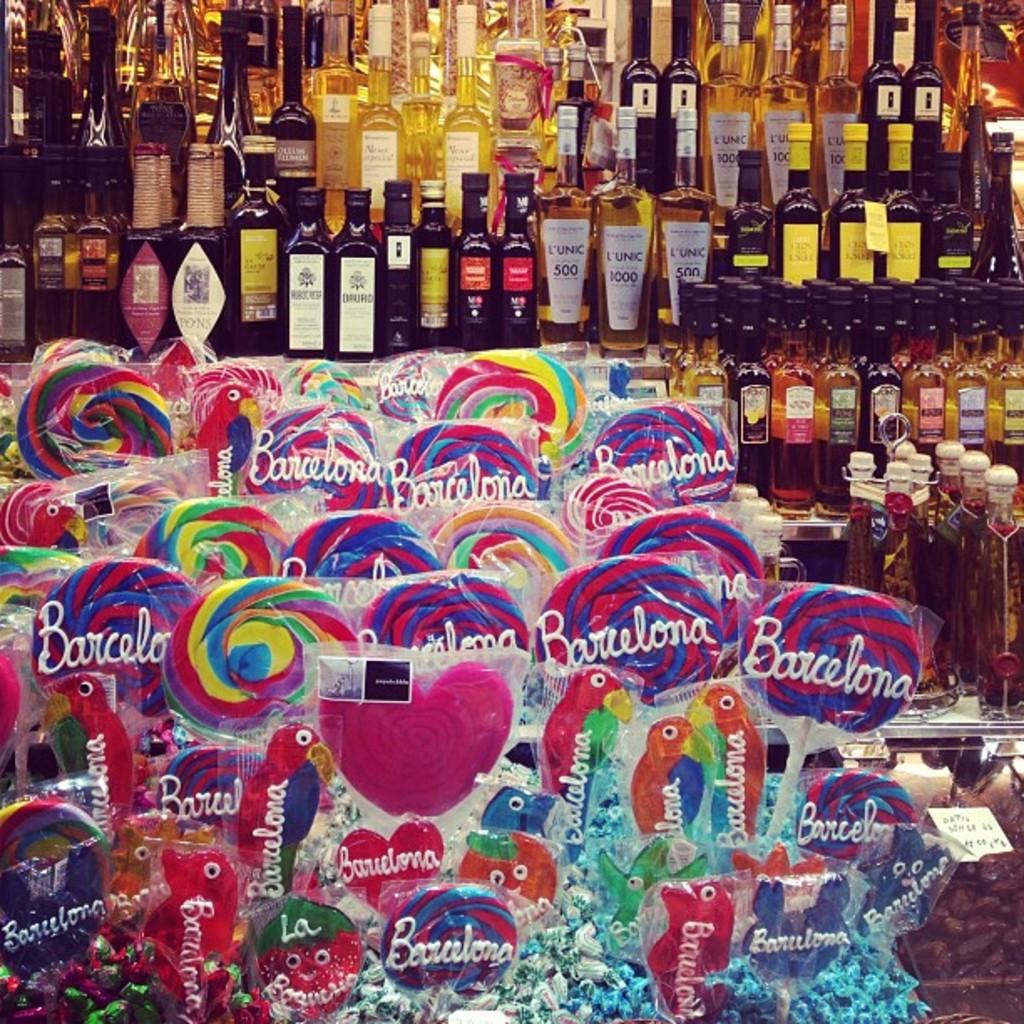What type of beverage containers are present in the image? There are wine bottles in the image. What type of candy is also visible in the image? There are lollipops in the image. Where is the scarecrow located in the image? There is no scarecrow present in the image. What type of payment method is accepted for the lollipops in the image? The image does not provide information about payment methods for the lollipops. 